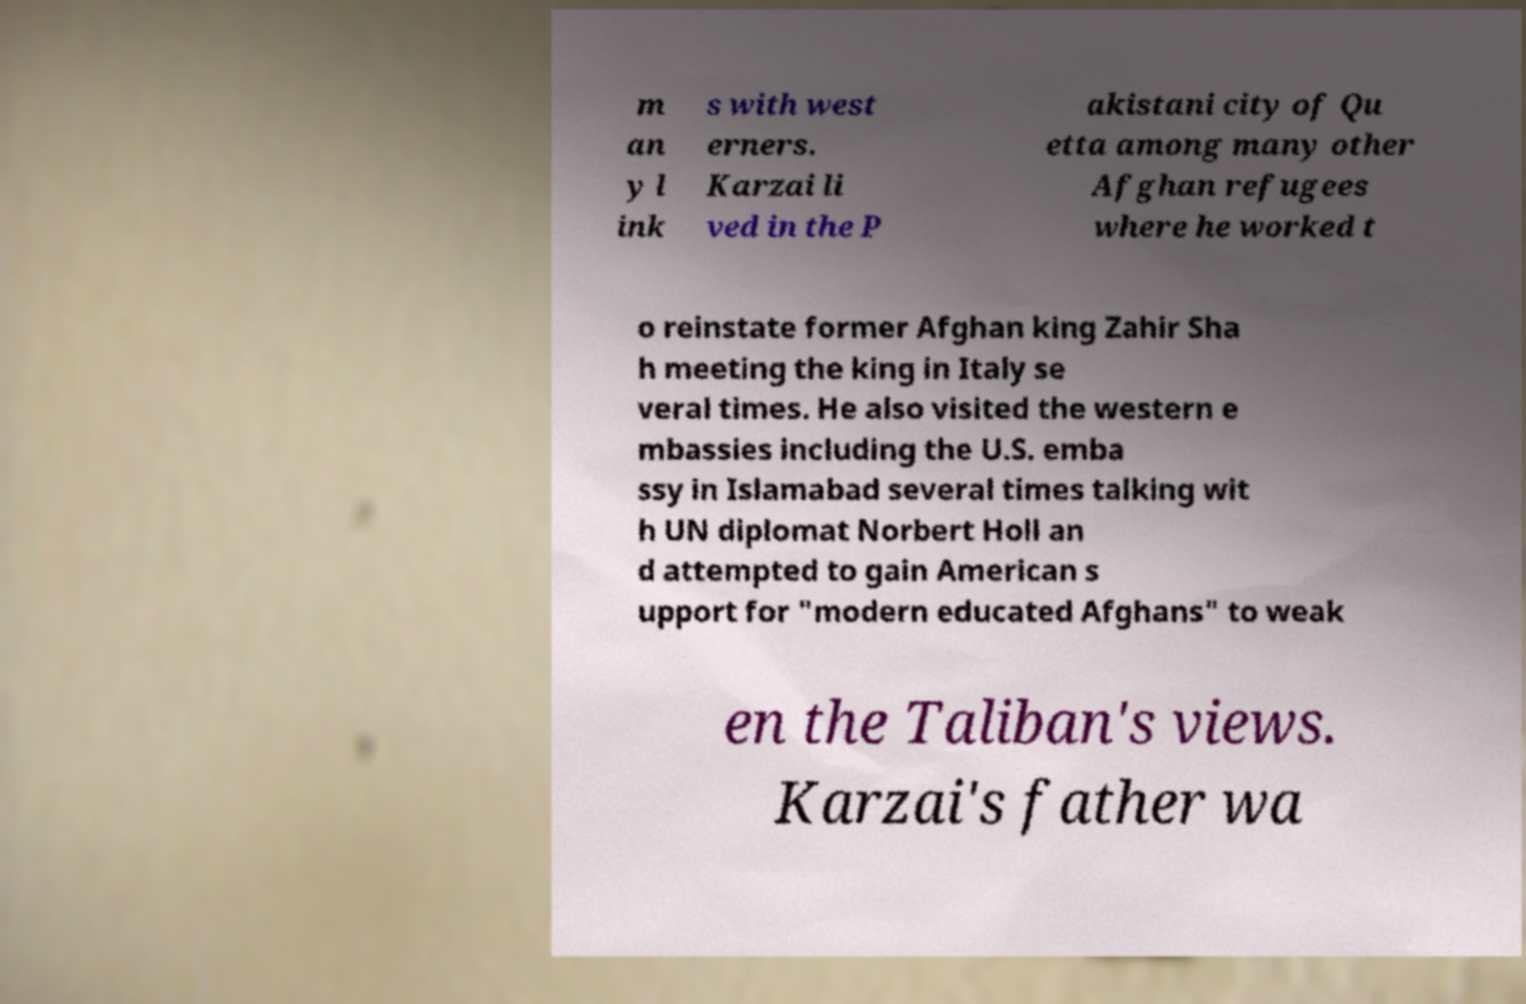Can you accurately transcribe the text from the provided image for me? m an y l ink s with west erners. Karzai li ved in the P akistani city of Qu etta among many other Afghan refugees where he worked t o reinstate former Afghan king Zahir Sha h meeting the king in Italy se veral times. He also visited the western e mbassies including the U.S. emba ssy in Islamabad several times talking wit h UN diplomat Norbert Holl an d attempted to gain American s upport for "modern educated Afghans" to weak en the Taliban's views. Karzai's father wa 